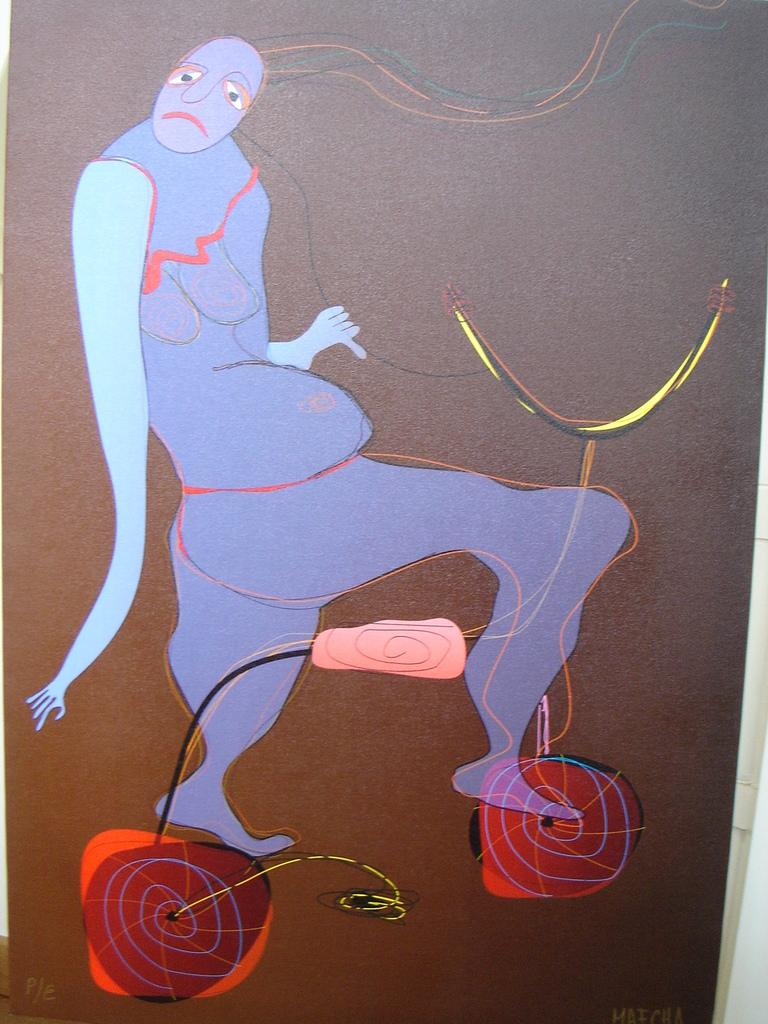What is the main subject of the image? The image contains an art of a person. What color is the background of the image? The background of the image is brown in color. Can you see any ghosts interacting with the person in the image? There are no ghosts present in the image. What type of sponge is being used by the person in the image? There is no sponge visible in the image. What organization is responsible for creating the art in the image? The provided facts do not mention any organization responsible for creating the art in the image. 